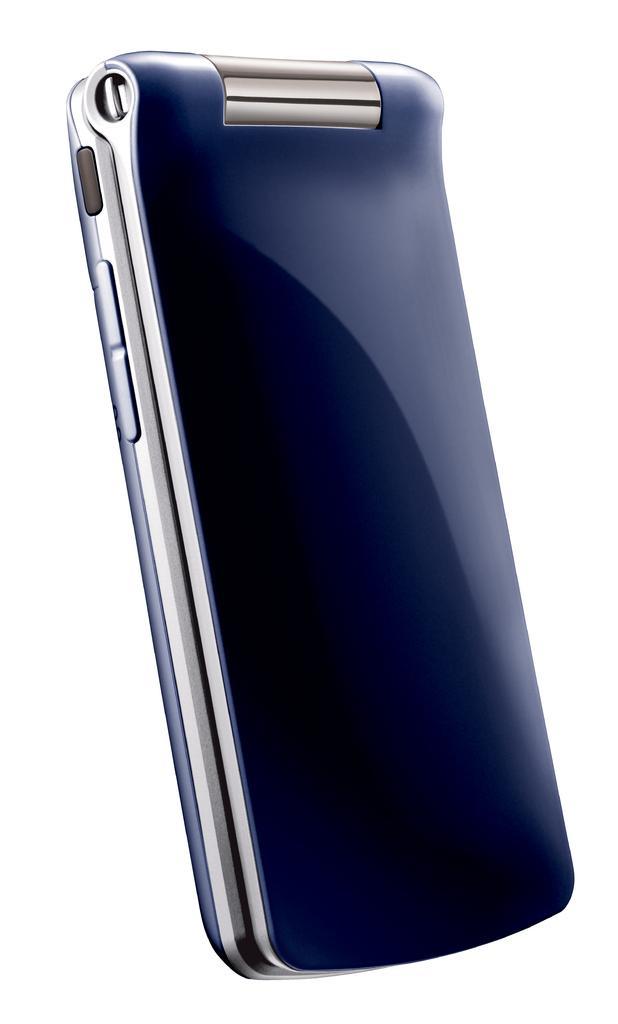In one or two sentences, can you explain what this image depicts? This picture consists of blue color phone and background color is white. 